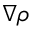Convert formula to latex. <formula><loc_0><loc_0><loc_500><loc_500>\nabla \rho</formula> 